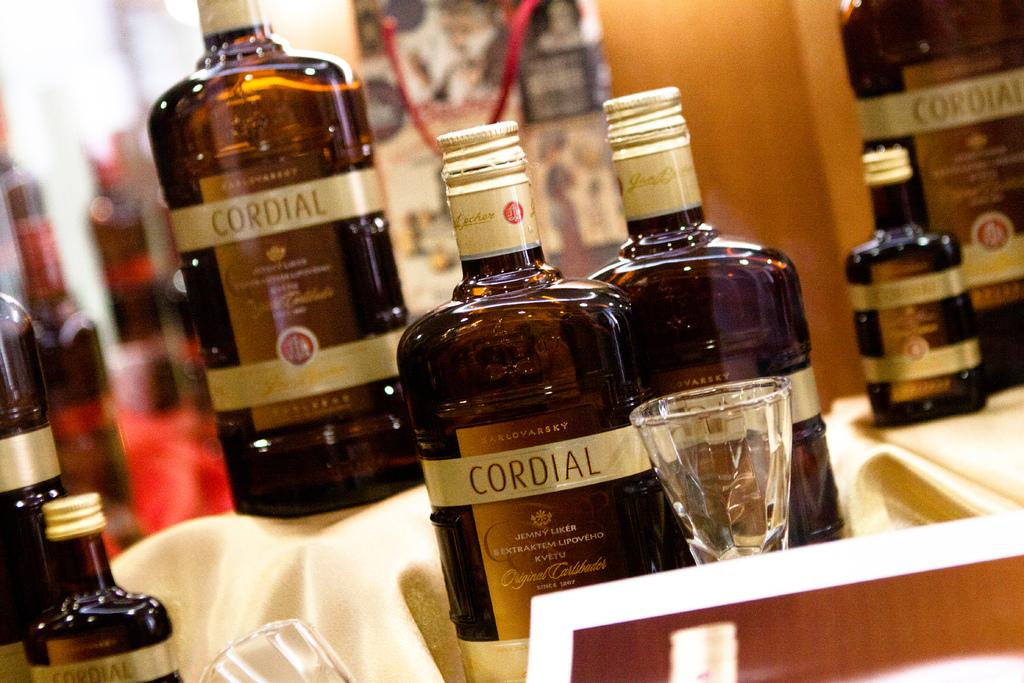What type of containers can be seen in the image? There are bottles and glasses in the image. Can you describe the contents of these containers? The provided facts do not specify the contents of the bottles and glasses. What type of pollution can be seen in the image? There is no reference to pollution in the image; it only features bottles and glasses. What type of duck is present in the image? There is no duck present in the image. 